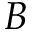Convert formula to latex. <formula><loc_0><loc_0><loc_500><loc_500>B</formula> 